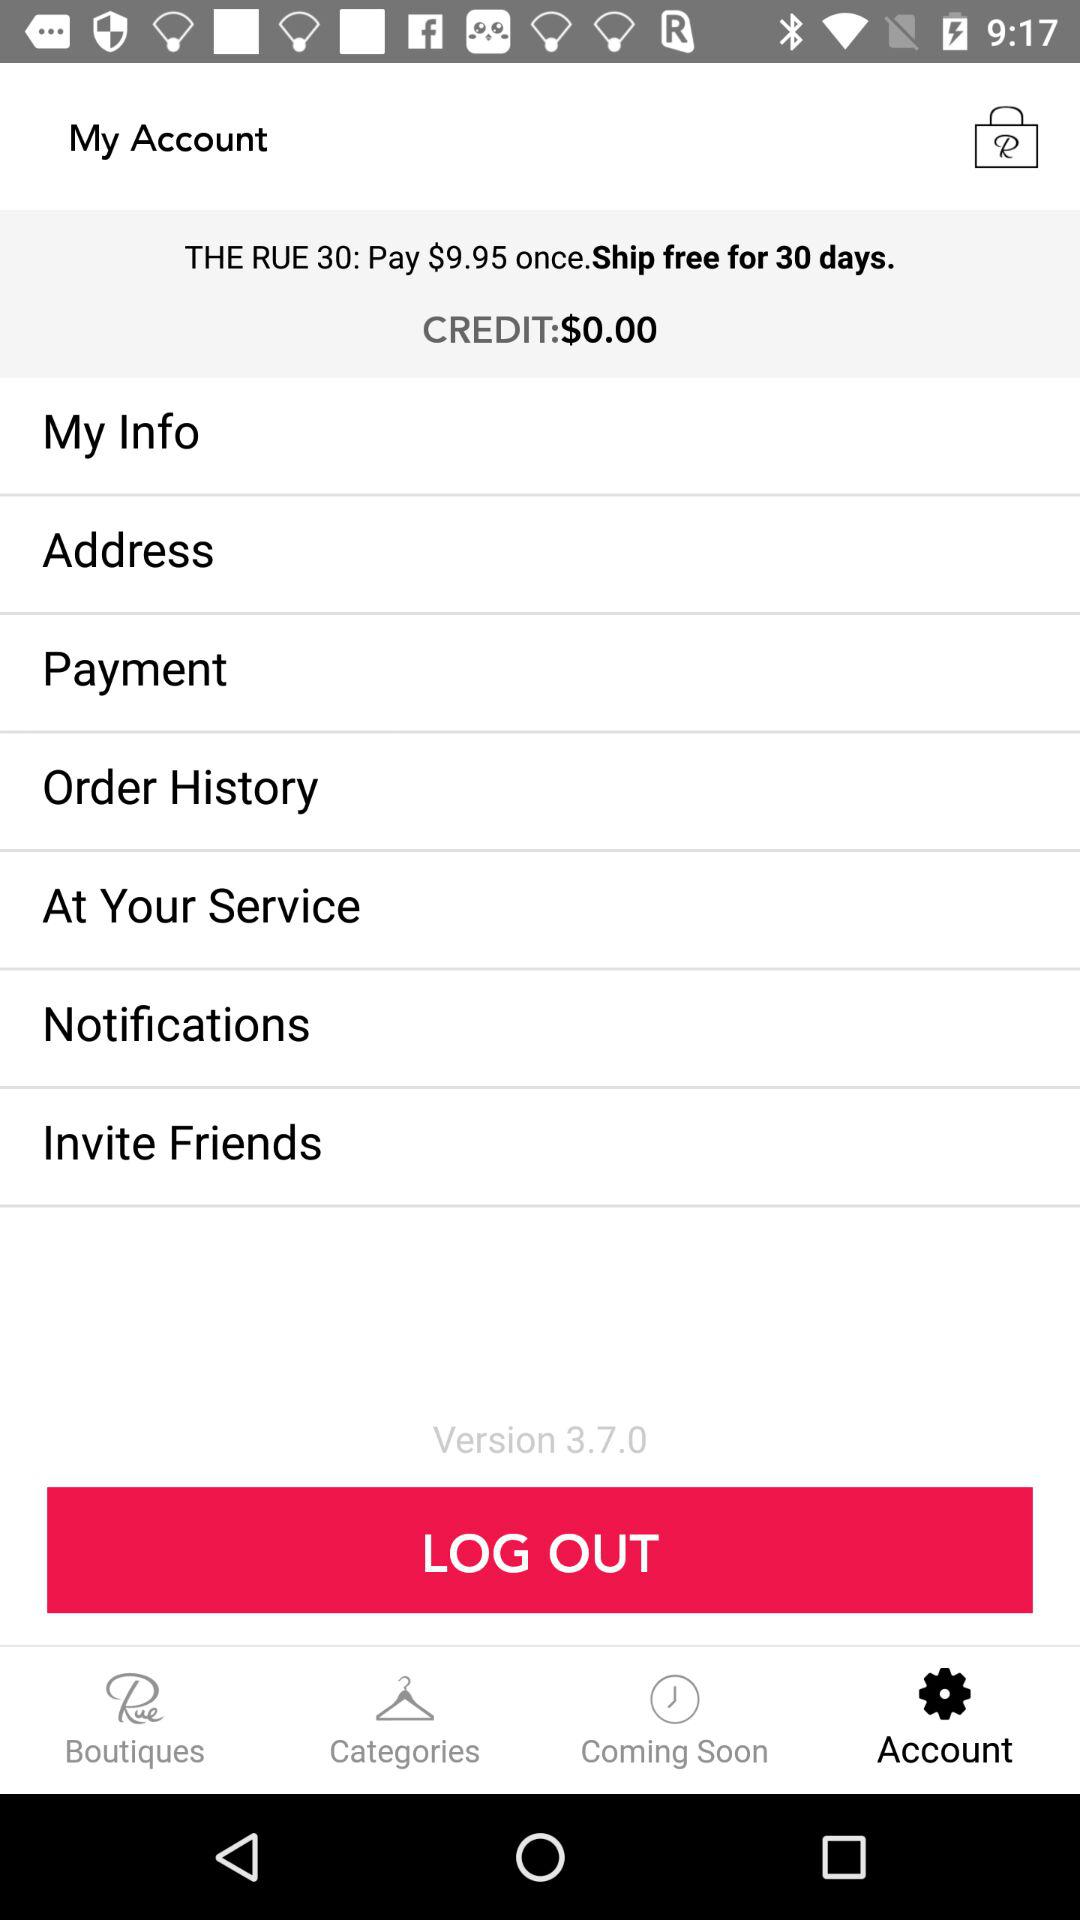Which tab is selected? The selected tab is "Account". 